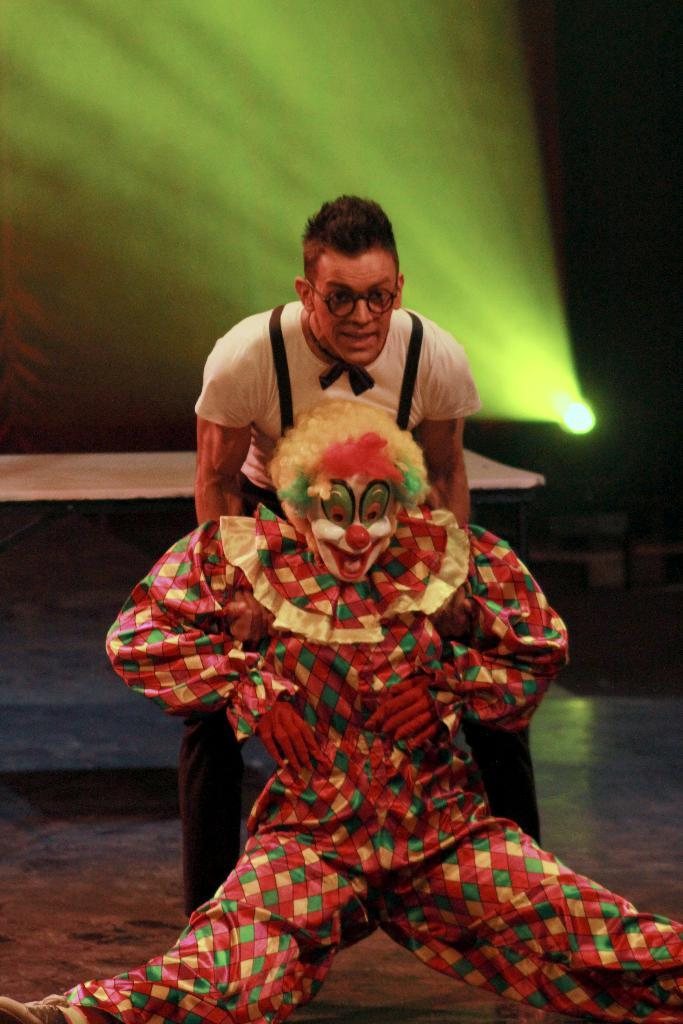How many people are in the image? There are two people in the image. What is the position of the people in the image? The people are on the ground. What can be seen in the background of the image? There is a wooden object and light visible in the background of the image. How many eggs are being used by the people in the image? There are no eggs present in the image. What year is depicted in the image? The image does not depict a specific year; it is a snapshot of a moment in time. 